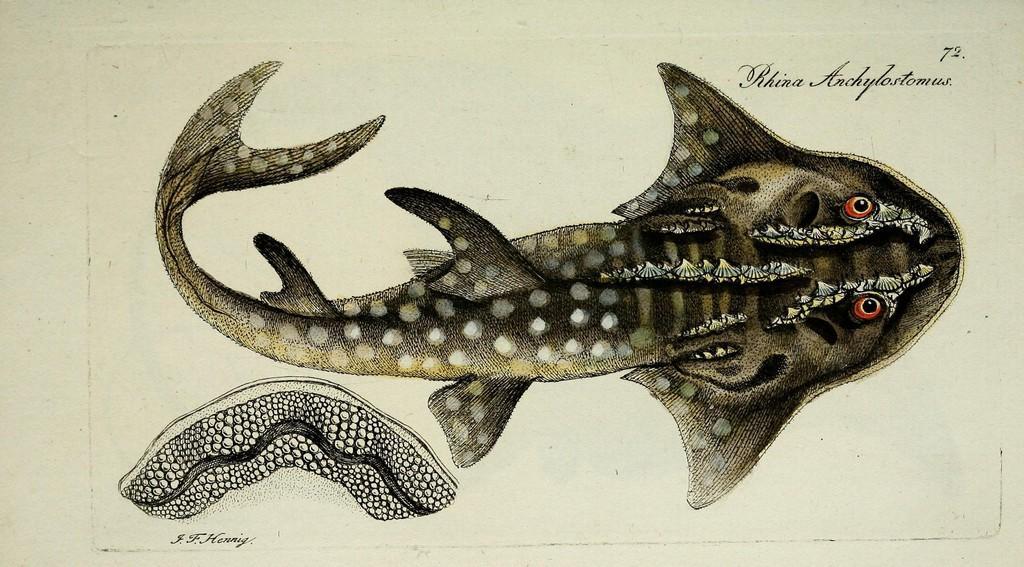Please provide a concise description of this image. In the image we can see there is a poster and there is fish on the poster. There are eyes on the fish and there are seashells on the fish. 